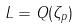Convert formula to latex. <formula><loc_0><loc_0><loc_500><loc_500>L = Q ( \zeta _ { p } )</formula> 